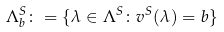Convert formula to latex. <formula><loc_0><loc_0><loc_500><loc_500>\Lambda ^ { S } _ { b } \colon = \{ \lambda \in \Lambda ^ { S } \colon v ^ { S } ( \lambda ) = b \}</formula> 